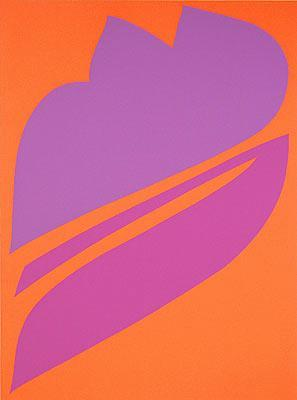Does this artwork remind you of any particular place or environment? This artwork's vibrant colors and organic shapes can evoke a sense of a lively, tropical environment. The bright orange background could represent the warmth and energy of a tropical sunset, while the purple form may remind one of exotic plants or flowers found in such a setting. The abstract nature of the piece allows for various interpretations, inviting the viewer to imagine a vivid and dynamic landscape. 